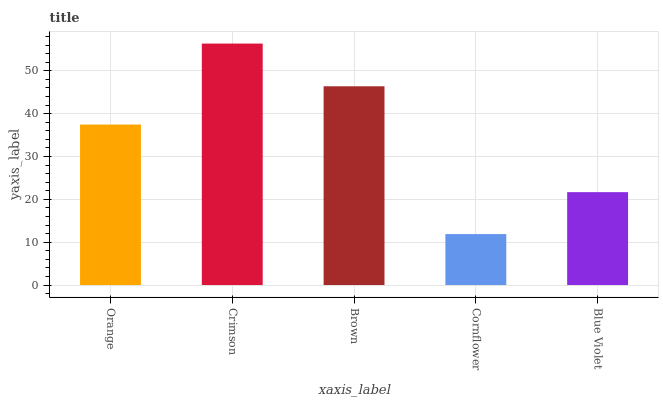Is Brown the minimum?
Answer yes or no. No. Is Brown the maximum?
Answer yes or no. No. Is Crimson greater than Brown?
Answer yes or no. Yes. Is Brown less than Crimson?
Answer yes or no. Yes. Is Brown greater than Crimson?
Answer yes or no. No. Is Crimson less than Brown?
Answer yes or no. No. Is Orange the high median?
Answer yes or no. Yes. Is Orange the low median?
Answer yes or no. Yes. Is Cornflower the high median?
Answer yes or no. No. Is Brown the low median?
Answer yes or no. No. 